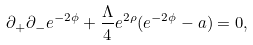Convert formula to latex. <formula><loc_0><loc_0><loc_500><loc_500>\partial _ { + } \partial _ { - } e ^ { - 2 \phi } + \frac { \Lambda } { 4 } e ^ { 2 \rho } ( e ^ { - 2 \phi } - a ) = 0 ,</formula> 